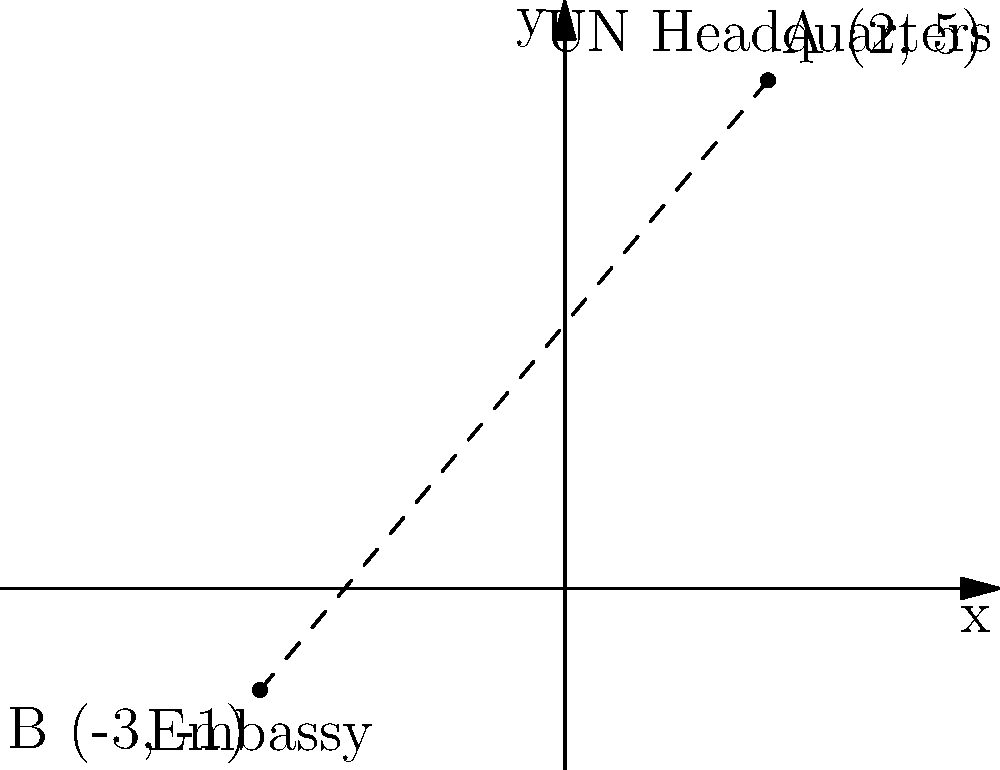On a city map represented by a coordinate plane, the UN Headquarters is located at point A (2, 5), and a foreign embassy is situated at point B (-3, -1). Calculate the straight-line distance between these two diplomatic missions using the distance formula. To find the distance between two points on a coordinate plane, we use the distance formula:

$$d = \sqrt{(x_2 - x_1)^2 + (y_2 - y_1)^2}$$

Where $(x_1, y_1)$ represents the coordinates of the first point and $(x_2, y_2)$ represents the coordinates of the second point.

Given:
Point A (UN Headquarters): $(x_1, y_1) = (2, 5)$
Point B (Embassy): $(x_2, y_2) = (-3, -1)$

Let's substitute these values into the formula:

$$d = \sqrt{(-3 - 2)^2 + (-1 - 5)^2}$$

Simplify inside the parentheses:
$$d = \sqrt{(-5)^2 + (-6)^2}$$

Calculate the squares:
$$d = \sqrt{25 + 36}$$

Add inside the square root:
$$d = \sqrt{61}$$

The distance between the two diplomatic missions is $\sqrt{61}$ units on the city map.
Answer: $\sqrt{61}$ units 